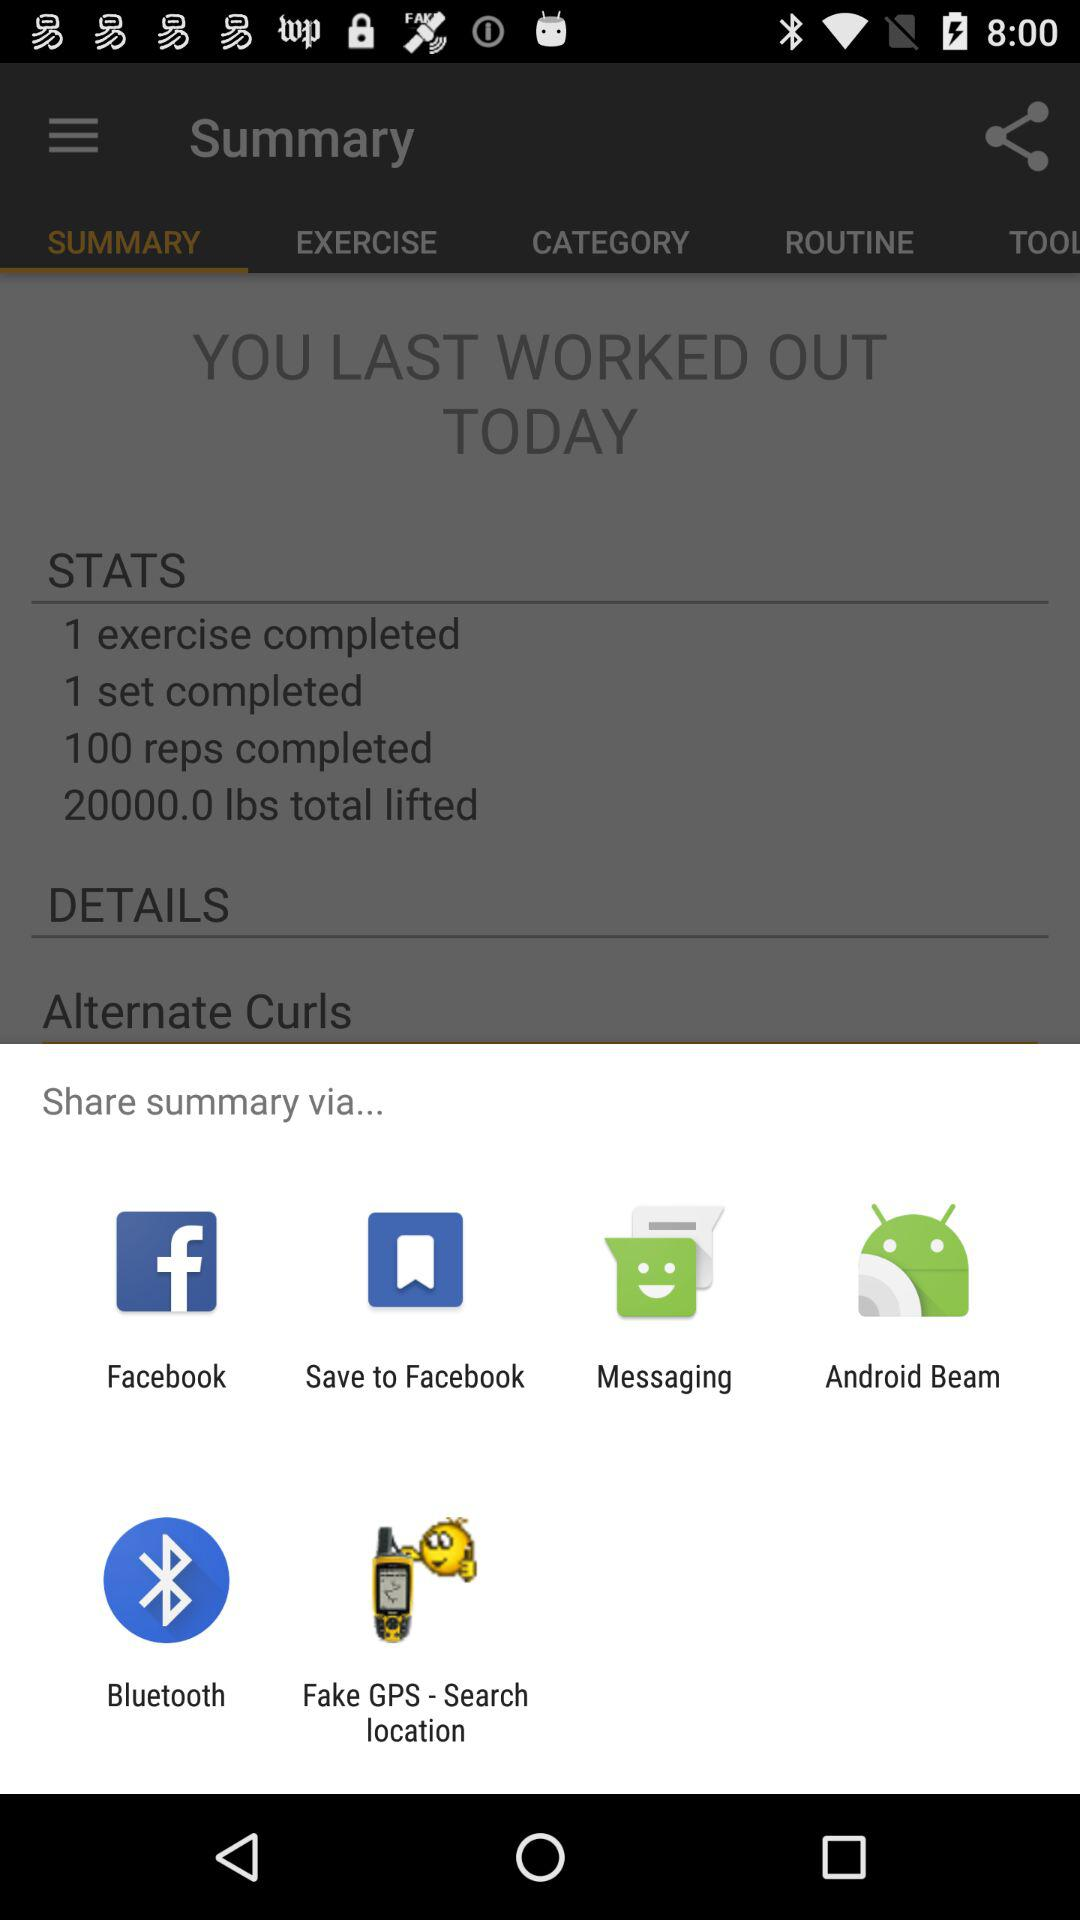With what app can we share the summary? You can share the summary with "Facebook", "Save to Facebook", "Messaging", "Android Beam", "Bluetooth", and "Fake GPS - Search location". 